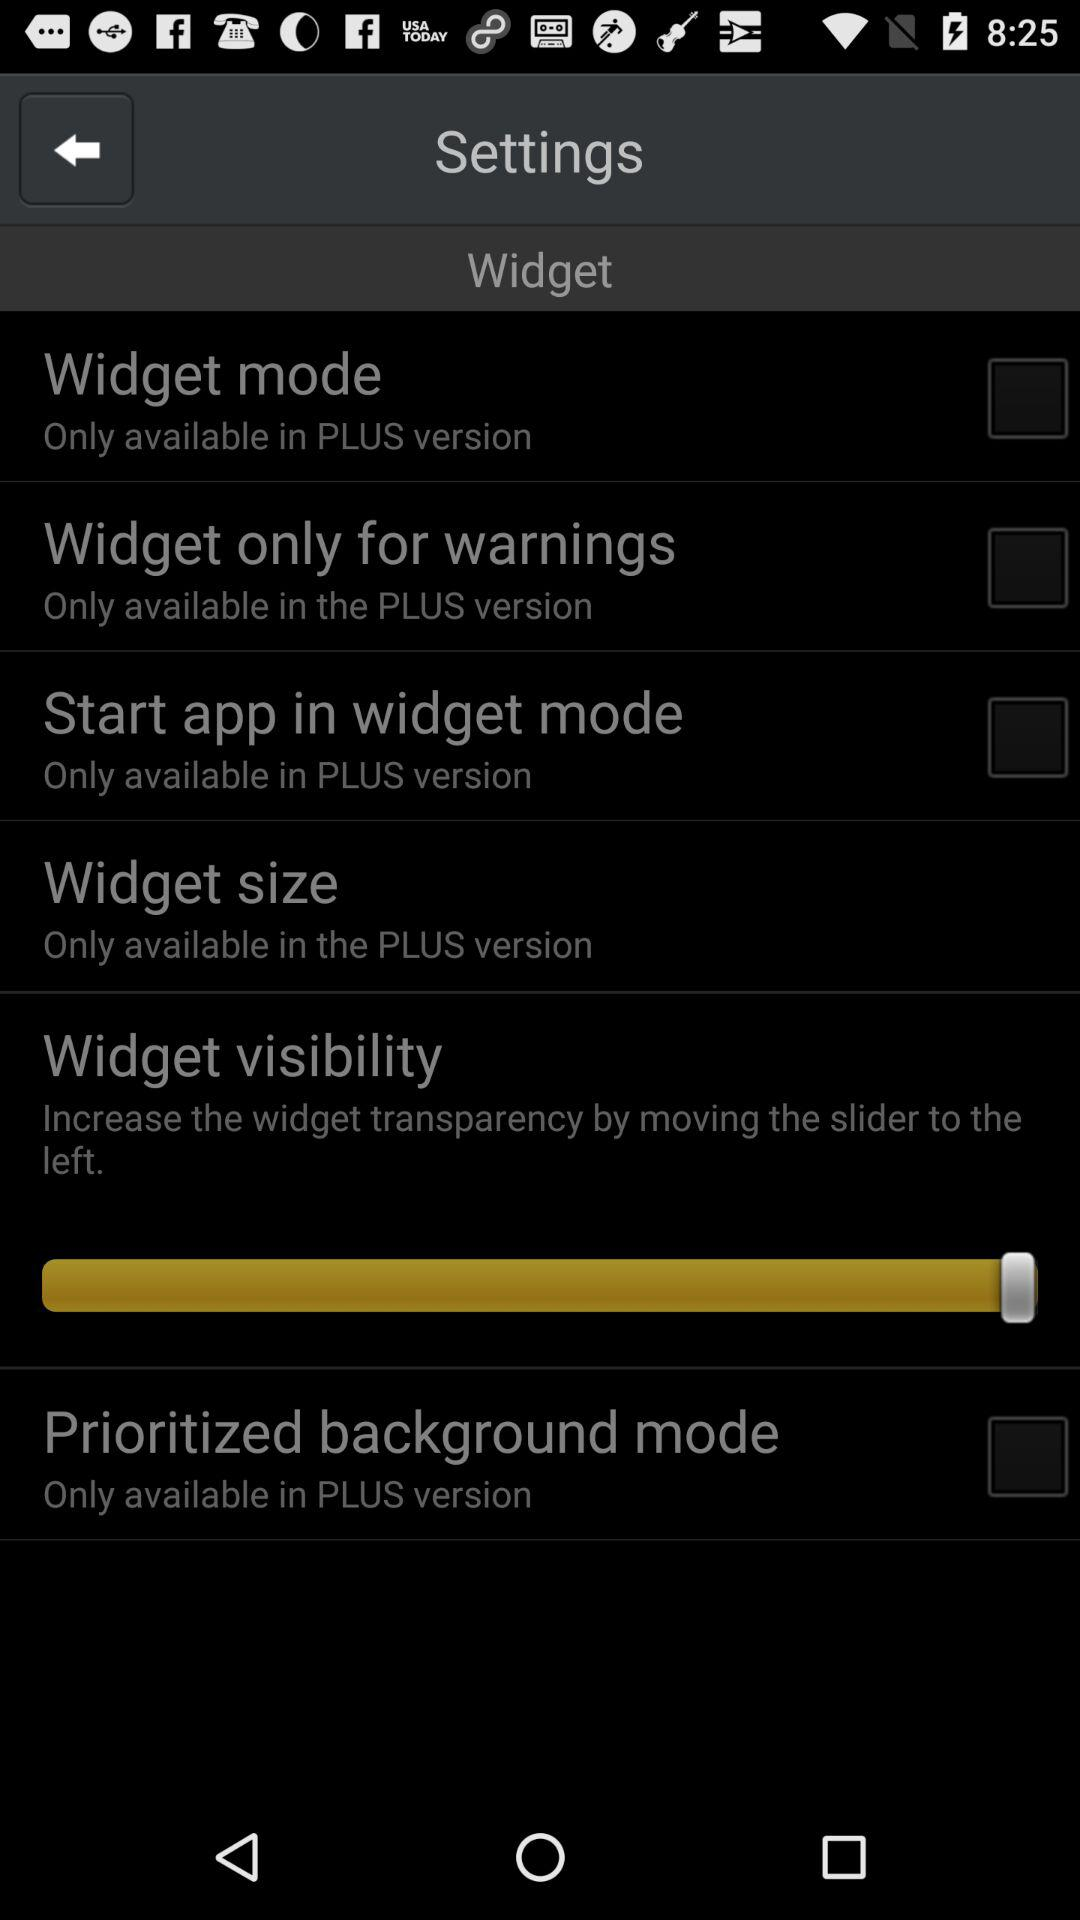What's the status of "Widget mode"? The status is "off". 